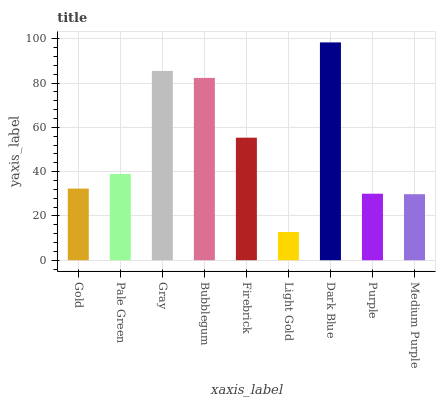Is Light Gold the minimum?
Answer yes or no. Yes. Is Dark Blue the maximum?
Answer yes or no. Yes. Is Pale Green the minimum?
Answer yes or no. No. Is Pale Green the maximum?
Answer yes or no. No. Is Pale Green greater than Gold?
Answer yes or no. Yes. Is Gold less than Pale Green?
Answer yes or no. Yes. Is Gold greater than Pale Green?
Answer yes or no. No. Is Pale Green less than Gold?
Answer yes or no. No. Is Pale Green the high median?
Answer yes or no. Yes. Is Pale Green the low median?
Answer yes or no. Yes. Is Purple the high median?
Answer yes or no. No. Is Firebrick the low median?
Answer yes or no. No. 